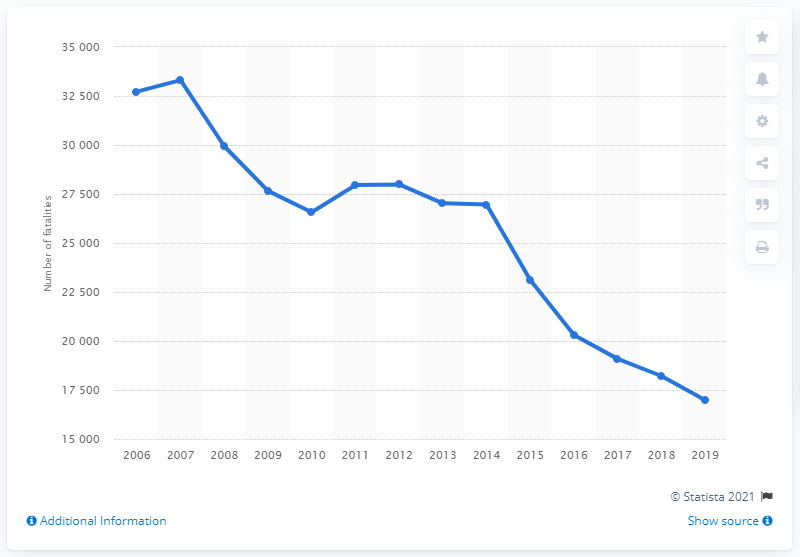Outline some significant characteristics in this image. In 2007, the highest volume of road fatalities was recorded in Russia. 